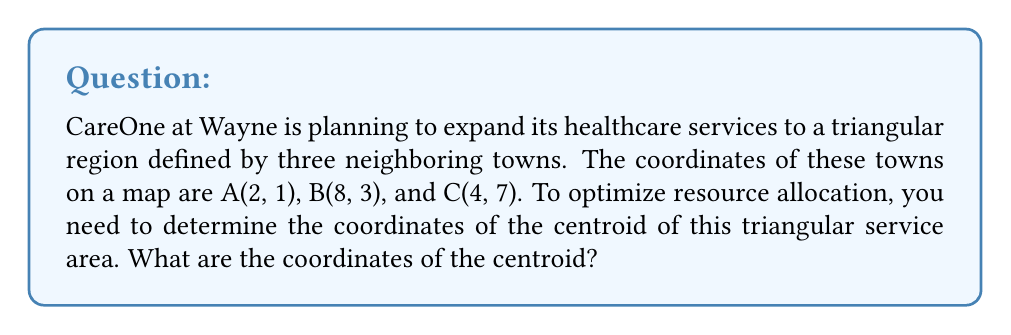Solve this math problem. To find the centroid of a triangle, we can use the following steps:

1. The centroid formula for a triangle with vertices $(x_1, y_1)$, $(x_2, y_2)$, and $(x_3, y_3)$ is:

   $$x_c = \frac{x_1 + x_2 + x_3}{3}$$
   $$y_c = \frac{y_1 + y_2 + y_3}{3}$$

2. We have the following coordinates:
   A(2, 1), B(8, 3), C(4, 7)

3. Let's substitute these values into our formulas:

   $$x_c = \frac{2 + 8 + 4}{3} = \frac{14}{3}$$
   $$y_c = \frac{1 + 3 + 7}{3} = \frac{11}{3}$$

4. Simplify:
   $$x_c = \frac{14}{3} \approx 4.67$$
   $$y_c = \frac{11}{3} \approx 3.67$$

Therefore, the coordinates of the centroid are $(\frac{14}{3}, \frac{11}{3})$ or approximately (4.67, 3.67).

[asy]
import geometry;

pair A = (2,1);
pair B = (8,3);
pair C = (4,7);
pair G = (14/3, 11/3);

draw(A--B--C--cycle, blue);
dot("A", A, SW);
dot("B", B, SE);
dot("C", C, N);
dot("G", G, NE);

xaxis(0,10,Arrow);
yaxis(0,8,Arrow);
[/asy]
Answer: $(\frac{14}{3}, \frac{11}{3})$ 